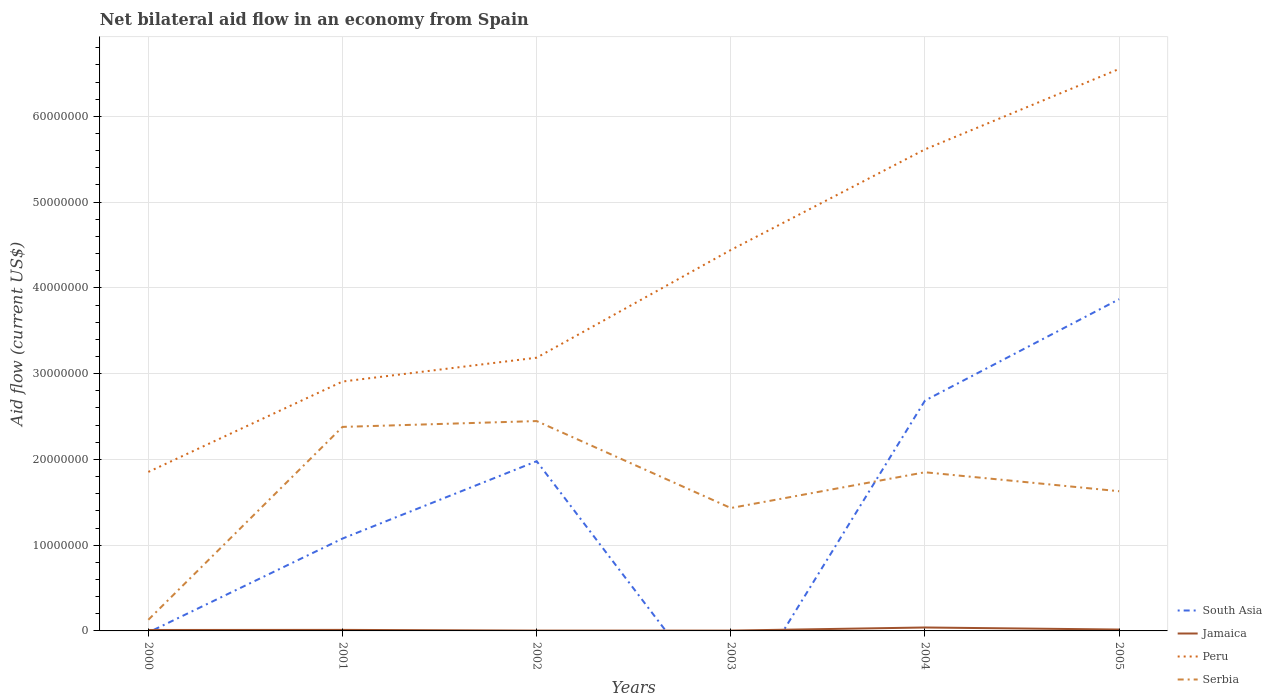Is the number of lines equal to the number of legend labels?
Offer a terse response. No. What is the total net bilateral aid flow in Peru in the graph?
Offer a very short reply. -2.71e+07. What is the difference between the highest and the second highest net bilateral aid flow in Peru?
Your answer should be compact. 4.70e+07. How many lines are there?
Offer a very short reply. 4. How many years are there in the graph?
Make the answer very short. 6. Are the values on the major ticks of Y-axis written in scientific E-notation?
Your answer should be compact. No. How many legend labels are there?
Keep it short and to the point. 4. What is the title of the graph?
Offer a terse response. Net bilateral aid flow in an economy from Spain. What is the label or title of the X-axis?
Keep it short and to the point. Years. What is the label or title of the Y-axis?
Ensure brevity in your answer.  Aid flow (current US$). What is the Aid flow (current US$) in South Asia in 2000?
Offer a terse response. 0. What is the Aid flow (current US$) of Peru in 2000?
Your answer should be very brief. 1.85e+07. What is the Aid flow (current US$) of Serbia in 2000?
Your answer should be compact. 1.30e+06. What is the Aid flow (current US$) in South Asia in 2001?
Your answer should be very brief. 1.08e+07. What is the Aid flow (current US$) of Peru in 2001?
Offer a very short reply. 2.91e+07. What is the Aid flow (current US$) in Serbia in 2001?
Your answer should be very brief. 2.38e+07. What is the Aid flow (current US$) in South Asia in 2002?
Make the answer very short. 1.98e+07. What is the Aid flow (current US$) of Jamaica in 2002?
Offer a terse response. 4.00e+04. What is the Aid flow (current US$) of Peru in 2002?
Give a very brief answer. 3.19e+07. What is the Aid flow (current US$) in Serbia in 2002?
Ensure brevity in your answer.  2.45e+07. What is the Aid flow (current US$) of South Asia in 2003?
Offer a terse response. 0. What is the Aid flow (current US$) in Peru in 2003?
Offer a very short reply. 4.44e+07. What is the Aid flow (current US$) in Serbia in 2003?
Ensure brevity in your answer.  1.43e+07. What is the Aid flow (current US$) of South Asia in 2004?
Your response must be concise. 2.69e+07. What is the Aid flow (current US$) of Jamaica in 2004?
Give a very brief answer. 4.00e+05. What is the Aid flow (current US$) in Peru in 2004?
Give a very brief answer. 5.62e+07. What is the Aid flow (current US$) in Serbia in 2004?
Your answer should be compact. 1.85e+07. What is the Aid flow (current US$) in South Asia in 2005?
Your response must be concise. 3.87e+07. What is the Aid flow (current US$) of Peru in 2005?
Ensure brevity in your answer.  6.55e+07. What is the Aid flow (current US$) in Serbia in 2005?
Your answer should be compact. 1.63e+07. Across all years, what is the maximum Aid flow (current US$) of South Asia?
Ensure brevity in your answer.  3.87e+07. Across all years, what is the maximum Aid flow (current US$) in Jamaica?
Your answer should be compact. 4.00e+05. Across all years, what is the maximum Aid flow (current US$) in Peru?
Offer a terse response. 6.55e+07. Across all years, what is the maximum Aid flow (current US$) in Serbia?
Provide a succinct answer. 2.45e+07. Across all years, what is the minimum Aid flow (current US$) in Jamaica?
Your response must be concise. 4.00e+04. Across all years, what is the minimum Aid flow (current US$) in Peru?
Provide a short and direct response. 1.85e+07. Across all years, what is the minimum Aid flow (current US$) in Serbia?
Give a very brief answer. 1.30e+06. What is the total Aid flow (current US$) of South Asia in the graph?
Ensure brevity in your answer.  9.61e+07. What is the total Aid flow (current US$) in Jamaica in the graph?
Offer a terse response. 8.70e+05. What is the total Aid flow (current US$) of Peru in the graph?
Offer a terse response. 2.46e+08. What is the total Aid flow (current US$) in Serbia in the graph?
Ensure brevity in your answer.  9.87e+07. What is the difference between the Aid flow (current US$) of Peru in 2000 and that in 2001?
Give a very brief answer. -1.05e+07. What is the difference between the Aid flow (current US$) in Serbia in 2000 and that in 2001?
Your answer should be compact. -2.25e+07. What is the difference between the Aid flow (current US$) of Jamaica in 2000 and that in 2002?
Make the answer very short. 7.00e+04. What is the difference between the Aid flow (current US$) of Peru in 2000 and that in 2002?
Ensure brevity in your answer.  -1.33e+07. What is the difference between the Aid flow (current US$) in Serbia in 2000 and that in 2002?
Provide a short and direct response. -2.32e+07. What is the difference between the Aid flow (current US$) of Jamaica in 2000 and that in 2003?
Your answer should be compact. 7.00e+04. What is the difference between the Aid flow (current US$) in Peru in 2000 and that in 2003?
Offer a terse response. -2.59e+07. What is the difference between the Aid flow (current US$) of Serbia in 2000 and that in 2003?
Provide a short and direct response. -1.30e+07. What is the difference between the Aid flow (current US$) of Jamaica in 2000 and that in 2004?
Offer a very short reply. -2.90e+05. What is the difference between the Aid flow (current US$) of Peru in 2000 and that in 2004?
Give a very brief answer. -3.76e+07. What is the difference between the Aid flow (current US$) of Serbia in 2000 and that in 2004?
Your response must be concise. -1.72e+07. What is the difference between the Aid flow (current US$) of Jamaica in 2000 and that in 2005?
Provide a short and direct response. -5.00e+04. What is the difference between the Aid flow (current US$) of Peru in 2000 and that in 2005?
Offer a terse response. -4.70e+07. What is the difference between the Aid flow (current US$) of Serbia in 2000 and that in 2005?
Give a very brief answer. -1.50e+07. What is the difference between the Aid flow (current US$) in South Asia in 2001 and that in 2002?
Offer a terse response. -9.02e+06. What is the difference between the Aid flow (current US$) in Jamaica in 2001 and that in 2002?
Offer a very short reply. 8.00e+04. What is the difference between the Aid flow (current US$) in Peru in 2001 and that in 2002?
Your answer should be compact. -2.78e+06. What is the difference between the Aid flow (current US$) of Serbia in 2001 and that in 2002?
Provide a short and direct response. -6.80e+05. What is the difference between the Aid flow (current US$) in Peru in 2001 and that in 2003?
Your answer should be compact. -1.53e+07. What is the difference between the Aid flow (current US$) of Serbia in 2001 and that in 2003?
Ensure brevity in your answer.  9.46e+06. What is the difference between the Aid flow (current US$) in South Asia in 2001 and that in 2004?
Your answer should be compact. -1.61e+07. What is the difference between the Aid flow (current US$) in Jamaica in 2001 and that in 2004?
Give a very brief answer. -2.80e+05. What is the difference between the Aid flow (current US$) in Peru in 2001 and that in 2004?
Make the answer very short. -2.71e+07. What is the difference between the Aid flow (current US$) of Serbia in 2001 and that in 2004?
Your answer should be compact. 5.29e+06. What is the difference between the Aid flow (current US$) in South Asia in 2001 and that in 2005?
Your answer should be very brief. -2.79e+07. What is the difference between the Aid flow (current US$) in Peru in 2001 and that in 2005?
Offer a very short reply. -3.64e+07. What is the difference between the Aid flow (current US$) in Serbia in 2001 and that in 2005?
Ensure brevity in your answer.  7.50e+06. What is the difference between the Aid flow (current US$) of Peru in 2002 and that in 2003?
Provide a short and direct response. -1.26e+07. What is the difference between the Aid flow (current US$) in Serbia in 2002 and that in 2003?
Provide a short and direct response. 1.01e+07. What is the difference between the Aid flow (current US$) of South Asia in 2002 and that in 2004?
Give a very brief answer. -7.07e+06. What is the difference between the Aid flow (current US$) of Jamaica in 2002 and that in 2004?
Make the answer very short. -3.60e+05. What is the difference between the Aid flow (current US$) in Peru in 2002 and that in 2004?
Give a very brief answer. -2.43e+07. What is the difference between the Aid flow (current US$) of Serbia in 2002 and that in 2004?
Offer a terse response. 5.97e+06. What is the difference between the Aid flow (current US$) of South Asia in 2002 and that in 2005?
Offer a very short reply. -1.89e+07. What is the difference between the Aid flow (current US$) in Peru in 2002 and that in 2005?
Make the answer very short. -3.37e+07. What is the difference between the Aid flow (current US$) in Serbia in 2002 and that in 2005?
Give a very brief answer. 8.18e+06. What is the difference between the Aid flow (current US$) of Jamaica in 2003 and that in 2004?
Provide a succinct answer. -3.60e+05. What is the difference between the Aid flow (current US$) in Peru in 2003 and that in 2004?
Your answer should be very brief. -1.17e+07. What is the difference between the Aid flow (current US$) of Serbia in 2003 and that in 2004?
Give a very brief answer. -4.17e+06. What is the difference between the Aid flow (current US$) of Jamaica in 2003 and that in 2005?
Your answer should be very brief. -1.20e+05. What is the difference between the Aid flow (current US$) of Peru in 2003 and that in 2005?
Your answer should be very brief. -2.11e+07. What is the difference between the Aid flow (current US$) in Serbia in 2003 and that in 2005?
Provide a succinct answer. -1.96e+06. What is the difference between the Aid flow (current US$) of South Asia in 2004 and that in 2005?
Give a very brief answer. -1.18e+07. What is the difference between the Aid flow (current US$) of Peru in 2004 and that in 2005?
Your answer should be very brief. -9.38e+06. What is the difference between the Aid flow (current US$) of Serbia in 2004 and that in 2005?
Your response must be concise. 2.21e+06. What is the difference between the Aid flow (current US$) of Jamaica in 2000 and the Aid flow (current US$) of Peru in 2001?
Your answer should be very brief. -2.90e+07. What is the difference between the Aid flow (current US$) in Jamaica in 2000 and the Aid flow (current US$) in Serbia in 2001?
Ensure brevity in your answer.  -2.37e+07. What is the difference between the Aid flow (current US$) of Peru in 2000 and the Aid flow (current US$) of Serbia in 2001?
Make the answer very short. -5.25e+06. What is the difference between the Aid flow (current US$) of Jamaica in 2000 and the Aid flow (current US$) of Peru in 2002?
Your answer should be compact. -3.18e+07. What is the difference between the Aid flow (current US$) of Jamaica in 2000 and the Aid flow (current US$) of Serbia in 2002?
Provide a succinct answer. -2.44e+07. What is the difference between the Aid flow (current US$) in Peru in 2000 and the Aid flow (current US$) in Serbia in 2002?
Your response must be concise. -5.93e+06. What is the difference between the Aid flow (current US$) in Jamaica in 2000 and the Aid flow (current US$) in Peru in 2003?
Keep it short and to the point. -4.43e+07. What is the difference between the Aid flow (current US$) in Jamaica in 2000 and the Aid flow (current US$) in Serbia in 2003?
Give a very brief answer. -1.42e+07. What is the difference between the Aid flow (current US$) of Peru in 2000 and the Aid flow (current US$) of Serbia in 2003?
Give a very brief answer. 4.21e+06. What is the difference between the Aid flow (current US$) of Jamaica in 2000 and the Aid flow (current US$) of Peru in 2004?
Ensure brevity in your answer.  -5.60e+07. What is the difference between the Aid flow (current US$) in Jamaica in 2000 and the Aid flow (current US$) in Serbia in 2004?
Make the answer very short. -1.84e+07. What is the difference between the Aid flow (current US$) of Peru in 2000 and the Aid flow (current US$) of Serbia in 2004?
Your answer should be compact. 4.00e+04. What is the difference between the Aid flow (current US$) in Jamaica in 2000 and the Aid flow (current US$) in Peru in 2005?
Ensure brevity in your answer.  -6.54e+07. What is the difference between the Aid flow (current US$) in Jamaica in 2000 and the Aid flow (current US$) in Serbia in 2005?
Your answer should be compact. -1.62e+07. What is the difference between the Aid flow (current US$) of Peru in 2000 and the Aid flow (current US$) of Serbia in 2005?
Provide a short and direct response. 2.25e+06. What is the difference between the Aid flow (current US$) of South Asia in 2001 and the Aid flow (current US$) of Jamaica in 2002?
Your response must be concise. 1.07e+07. What is the difference between the Aid flow (current US$) of South Asia in 2001 and the Aid flow (current US$) of Peru in 2002?
Ensure brevity in your answer.  -2.11e+07. What is the difference between the Aid flow (current US$) of South Asia in 2001 and the Aid flow (current US$) of Serbia in 2002?
Ensure brevity in your answer.  -1.37e+07. What is the difference between the Aid flow (current US$) of Jamaica in 2001 and the Aid flow (current US$) of Peru in 2002?
Provide a succinct answer. -3.17e+07. What is the difference between the Aid flow (current US$) of Jamaica in 2001 and the Aid flow (current US$) of Serbia in 2002?
Give a very brief answer. -2.44e+07. What is the difference between the Aid flow (current US$) of Peru in 2001 and the Aid flow (current US$) of Serbia in 2002?
Offer a very short reply. 4.61e+06. What is the difference between the Aid flow (current US$) in South Asia in 2001 and the Aid flow (current US$) in Jamaica in 2003?
Offer a very short reply. 1.07e+07. What is the difference between the Aid flow (current US$) in South Asia in 2001 and the Aid flow (current US$) in Peru in 2003?
Make the answer very short. -3.36e+07. What is the difference between the Aid flow (current US$) of South Asia in 2001 and the Aid flow (current US$) of Serbia in 2003?
Give a very brief answer. -3.56e+06. What is the difference between the Aid flow (current US$) of Jamaica in 2001 and the Aid flow (current US$) of Peru in 2003?
Offer a terse response. -4.43e+07. What is the difference between the Aid flow (current US$) in Jamaica in 2001 and the Aid flow (current US$) in Serbia in 2003?
Give a very brief answer. -1.42e+07. What is the difference between the Aid flow (current US$) in Peru in 2001 and the Aid flow (current US$) in Serbia in 2003?
Make the answer very short. 1.48e+07. What is the difference between the Aid flow (current US$) of South Asia in 2001 and the Aid flow (current US$) of Jamaica in 2004?
Ensure brevity in your answer.  1.04e+07. What is the difference between the Aid flow (current US$) of South Asia in 2001 and the Aid flow (current US$) of Peru in 2004?
Offer a very short reply. -4.54e+07. What is the difference between the Aid flow (current US$) in South Asia in 2001 and the Aid flow (current US$) in Serbia in 2004?
Offer a terse response. -7.73e+06. What is the difference between the Aid flow (current US$) of Jamaica in 2001 and the Aid flow (current US$) of Peru in 2004?
Provide a succinct answer. -5.60e+07. What is the difference between the Aid flow (current US$) in Jamaica in 2001 and the Aid flow (current US$) in Serbia in 2004?
Your answer should be very brief. -1.84e+07. What is the difference between the Aid flow (current US$) of Peru in 2001 and the Aid flow (current US$) of Serbia in 2004?
Make the answer very short. 1.06e+07. What is the difference between the Aid flow (current US$) of South Asia in 2001 and the Aid flow (current US$) of Jamaica in 2005?
Make the answer very short. 1.06e+07. What is the difference between the Aid flow (current US$) in South Asia in 2001 and the Aid flow (current US$) in Peru in 2005?
Provide a short and direct response. -5.48e+07. What is the difference between the Aid flow (current US$) of South Asia in 2001 and the Aid flow (current US$) of Serbia in 2005?
Give a very brief answer. -5.52e+06. What is the difference between the Aid flow (current US$) in Jamaica in 2001 and the Aid flow (current US$) in Peru in 2005?
Provide a succinct answer. -6.54e+07. What is the difference between the Aid flow (current US$) in Jamaica in 2001 and the Aid flow (current US$) in Serbia in 2005?
Keep it short and to the point. -1.62e+07. What is the difference between the Aid flow (current US$) of Peru in 2001 and the Aid flow (current US$) of Serbia in 2005?
Provide a succinct answer. 1.28e+07. What is the difference between the Aid flow (current US$) in South Asia in 2002 and the Aid flow (current US$) in Jamaica in 2003?
Your answer should be compact. 1.98e+07. What is the difference between the Aid flow (current US$) of South Asia in 2002 and the Aid flow (current US$) of Peru in 2003?
Your response must be concise. -2.46e+07. What is the difference between the Aid flow (current US$) of South Asia in 2002 and the Aid flow (current US$) of Serbia in 2003?
Offer a terse response. 5.46e+06. What is the difference between the Aid flow (current US$) of Jamaica in 2002 and the Aid flow (current US$) of Peru in 2003?
Your response must be concise. -4.44e+07. What is the difference between the Aid flow (current US$) in Jamaica in 2002 and the Aid flow (current US$) in Serbia in 2003?
Offer a very short reply. -1.43e+07. What is the difference between the Aid flow (current US$) of Peru in 2002 and the Aid flow (current US$) of Serbia in 2003?
Offer a very short reply. 1.75e+07. What is the difference between the Aid flow (current US$) of South Asia in 2002 and the Aid flow (current US$) of Jamaica in 2004?
Provide a short and direct response. 1.94e+07. What is the difference between the Aid flow (current US$) in South Asia in 2002 and the Aid flow (current US$) in Peru in 2004?
Provide a succinct answer. -3.64e+07. What is the difference between the Aid flow (current US$) of South Asia in 2002 and the Aid flow (current US$) of Serbia in 2004?
Give a very brief answer. 1.29e+06. What is the difference between the Aid flow (current US$) in Jamaica in 2002 and the Aid flow (current US$) in Peru in 2004?
Provide a short and direct response. -5.61e+07. What is the difference between the Aid flow (current US$) in Jamaica in 2002 and the Aid flow (current US$) in Serbia in 2004?
Offer a very short reply. -1.85e+07. What is the difference between the Aid flow (current US$) in Peru in 2002 and the Aid flow (current US$) in Serbia in 2004?
Your response must be concise. 1.34e+07. What is the difference between the Aid flow (current US$) in South Asia in 2002 and the Aid flow (current US$) in Jamaica in 2005?
Give a very brief answer. 1.96e+07. What is the difference between the Aid flow (current US$) in South Asia in 2002 and the Aid flow (current US$) in Peru in 2005?
Your answer should be very brief. -4.57e+07. What is the difference between the Aid flow (current US$) of South Asia in 2002 and the Aid flow (current US$) of Serbia in 2005?
Your answer should be compact. 3.50e+06. What is the difference between the Aid flow (current US$) in Jamaica in 2002 and the Aid flow (current US$) in Peru in 2005?
Provide a succinct answer. -6.55e+07. What is the difference between the Aid flow (current US$) in Jamaica in 2002 and the Aid flow (current US$) in Serbia in 2005?
Keep it short and to the point. -1.62e+07. What is the difference between the Aid flow (current US$) in Peru in 2002 and the Aid flow (current US$) in Serbia in 2005?
Provide a short and direct response. 1.56e+07. What is the difference between the Aid flow (current US$) in Jamaica in 2003 and the Aid flow (current US$) in Peru in 2004?
Your answer should be very brief. -5.61e+07. What is the difference between the Aid flow (current US$) in Jamaica in 2003 and the Aid flow (current US$) in Serbia in 2004?
Give a very brief answer. -1.85e+07. What is the difference between the Aid flow (current US$) of Peru in 2003 and the Aid flow (current US$) of Serbia in 2004?
Provide a succinct answer. 2.59e+07. What is the difference between the Aid flow (current US$) in Jamaica in 2003 and the Aid flow (current US$) in Peru in 2005?
Provide a short and direct response. -6.55e+07. What is the difference between the Aid flow (current US$) in Jamaica in 2003 and the Aid flow (current US$) in Serbia in 2005?
Offer a terse response. -1.62e+07. What is the difference between the Aid flow (current US$) of Peru in 2003 and the Aid flow (current US$) of Serbia in 2005?
Keep it short and to the point. 2.81e+07. What is the difference between the Aid flow (current US$) of South Asia in 2004 and the Aid flow (current US$) of Jamaica in 2005?
Your answer should be compact. 2.67e+07. What is the difference between the Aid flow (current US$) of South Asia in 2004 and the Aid flow (current US$) of Peru in 2005?
Ensure brevity in your answer.  -3.87e+07. What is the difference between the Aid flow (current US$) of South Asia in 2004 and the Aid flow (current US$) of Serbia in 2005?
Provide a short and direct response. 1.06e+07. What is the difference between the Aid flow (current US$) of Jamaica in 2004 and the Aid flow (current US$) of Peru in 2005?
Give a very brief answer. -6.51e+07. What is the difference between the Aid flow (current US$) in Jamaica in 2004 and the Aid flow (current US$) in Serbia in 2005?
Keep it short and to the point. -1.59e+07. What is the difference between the Aid flow (current US$) in Peru in 2004 and the Aid flow (current US$) in Serbia in 2005?
Provide a succinct answer. 3.99e+07. What is the average Aid flow (current US$) of South Asia per year?
Offer a very short reply. 1.60e+07. What is the average Aid flow (current US$) of Jamaica per year?
Your answer should be very brief. 1.45e+05. What is the average Aid flow (current US$) in Peru per year?
Your answer should be very brief. 4.09e+07. What is the average Aid flow (current US$) of Serbia per year?
Provide a short and direct response. 1.64e+07. In the year 2000, what is the difference between the Aid flow (current US$) of Jamaica and Aid flow (current US$) of Peru?
Give a very brief answer. -1.84e+07. In the year 2000, what is the difference between the Aid flow (current US$) in Jamaica and Aid flow (current US$) in Serbia?
Give a very brief answer. -1.19e+06. In the year 2000, what is the difference between the Aid flow (current US$) in Peru and Aid flow (current US$) in Serbia?
Offer a very short reply. 1.72e+07. In the year 2001, what is the difference between the Aid flow (current US$) of South Asia and Aid flow (current US$) of Jamaica?
Your response must be concise. 1.06e+07. In the year 2001, what is the difference between the Aid flow (current US$) of South Asia and Aid flow (current US$) of Peru?
Your answer should be compact. -1.83e+07. In the year 2001, what is the difference between the Aid flow (current US$) of South Asia and Aid flow (current US$) of Serbia?
Make the answer very short. -1.30e+07. In the year 2001, what is the difference between the Aid flow (current US$) in Jamaica and Aid flow (current US$) in Peru?
Ensure brevity in your answer.  -2.90e+07. In the year 2001, what is the difference between the Aid flow (current US$) in Jamaica and Aid flow (current US$) in Serbia?
Keep it short and to the point. -2.37e+07. In the year 2001, what is the difference between the Aid flow (current US$) in Peru and Aid flow (current US$) in Serbia?
Offer a very short reply. 5.29e+06. In the year 2002, what is the difference between the Aid flow (current US$) of South Asia and Aid flow (current US$) of Jamaica?
Your response must be concise. 1.98e+07. In the year 2002, what is the difference between the Aid flow (current US$) of South Asia and Aid flow (current US$) of Peru?
Provide a succinct answer. -1.21e+07. In the year 2002, what is the difference between the Aid flow (current US$) of South Asia and Aid flow (current US$) of Serbia?
Keep it short and to the point. -4.68e+06. In the year 2002, what is the difference between the Aid flow (current US$) in Jamaica and Aid flow (current US$) in Peru?
Your answer should be very brief. -3.18e+07. In the year 2002, what is the difference between the Aid flow (current US$) in Jamaica and Aid flow (current US$) in Serbia?
Ensure brevity in your answer.  -2.44e+07. In the year 2002, what is the difference between the Aid flow (current US$) of Peru and Aid flow (current US$) of Serbia?
Your answer should be very brief. 7.39e+06. In the year 2003, what is the difference between the Aid flow (current US$) of Jamaica and Aid flow (current US$) of Peru?
Make the answer very short. -4.44e+07. In the year 2003, what is the difference between the Aid flow (current US$) in Jamaica and Aid flow (current US$) in Serbia?
Give a very brief answer. -1.43e+07. In the year 2003, what is the difference between the Aid flow (current US$) of Peru and Aid flow (current US$) of Serbia?
Your answer should be compact. 3.01e+07. In the year 2004, what is the difference between the Aid flow (current US$) of South Asia and Aid flow (current US$) of Jamaica?
Your answer should be compact. 2.65e+07. In the year 2004, what is the difference between the Aid flow (current US$) in South Asia and Aid flow (current US$) in Peru?
Make the answer very short. -2.93e+07. In the year 2004, what is the difference between the Aid flow (current US$) of South Asia and Aid flow (current US$) of Serbia?
Provide a succinct answer. 8.36e+06. In the year 2004, what is the difference between the Aid flow (current US$) in Jamaica and Aid flow (current US$) in Peru?
Offer a very short reply. -5.58e+07. In the year 2004, what is the difference between the Aid flow (current US$) of Jamaica and Aid flow (current US$) of Serbia?
Make the answer very short. -1.81e+07. In the year 2004, what is the difference between the Aid flow (current US$) in Peru and Aid flow (current US$) in Serbia?
Your answer should be compact. 3.76e+07. In the year 2005, what is the difference between the Aid flow (current US$) of South Asia and Aid flow (current US$) of Jamaica?
Ensure brevity in your answer.  3.85e+07. In the year 2005, what is the difference between the Aid flow (current US$) of South Asia and Aid flow (current US$) of Peru?
Provide a short and direct response. -2.68e+07. In the year 2005, what is the difference between the Aid flow (current US$) in South Asia and Aid flow (current US$) in Serbia?
Provide a succinct answer. 2.24e+07. In the year 2005, what is the difference between the Aid flow (current US$) of Jamaica and Aid flow (current US$) of Peru?
Make the answer very short. -6.54e+07. In the year 2005, what is the difference between the Aid flow (current US$) of Jamaica and Aid flow (current US$) of Serbia?
Provide a succinct answer. -1.61e+07. In the year 2005, what is the difference between the Aid flow (current US$) in Peru and Aid flow (current US$) in Serbia?
Give a very brief answer. 4.92e+07. What is the ratio of the Aid flow (current US$) of Peru in 2000 to that in 2001?
Your answer should be very brief. 0.64. What is the ratio of the Aid flow (current US$) in Serbia in 2000 to that in 2001?
Offer a terse response. 0.05. What is the ratio of the Aid flow (current US$) in Jamaica in 2000 to that in 2002?
Provide a short and direct response. 2.75. What is the ratio of the Aid flow (current US$) of Peru in 2000 to that in 2002?
Your answer should be compact. 0.58. What is the ratio of the Aid flow (current US$) of Serbia in 2000 to that in 2002?
Keep it short and to the point. 0.05. What is the ratio of the Aid flow (current US$) in Jamaica in 2000 to that in 2003?
Provide a succinct answer. 2.75. What is the ratio of the Aid flow (current US$) of Peru in 2000 to that in 2003?
Ensure brevity in your answer.  0.42. What is the ratio of the Aid flow (current US$) in Serbia in 2000 to that in 2003?
Make the answer very short. 0.09. What is the ratio of the Aid flow (current US$) in Jamaica in 2000 to that in 2004?
Ensure brevity in your answer.  0.28. What is the ratio of the Aid flow (current US$) in Peru in 2000 to that in 2004?
Provide a short and direct response. 0.33. What is the ratio of the Aid flow (current US$) in Serbia in 2000 to that in 2004?
Your answer should be compact. 0.07. What is the ratio of the Aid flow (current US$) in Jamaica in 2000 to that in 2005?
Give a very brief answer. 0.69. What is the ratio of the Aid flow (current US$) of Peru in 2000 to that in 2005?
Your response must be concise. 0.28. What is the ratio of the Aid flow (current US$) of Serbia in 2000 to that in 2005?
Give a very brief answer. 0.08. What is the ratio of the Aid flow (current US$) in South Asia in 2001 to that in 2002?
Provide a succinct answer. 0.54. What is the ratio of the Aid flow (current US$) in Jamaica in 2001 to that in 2002?
Ensure brevity in your answer.  3. What is the ratio of the Aid flow (current US$) in Peru in 2001 to that in 2002?
Provide a succinct answer. 0.91. What is the ratio of the Aid flow (current US$) of Serbia in 2001 to that in 2002?
Keep it short and to the point. 0.97. What is the ratio of the Aid flow (current US$) of Peru in 2001 to that in 2003?
Make the answer very short. 0.65. What is the ratio of the Aid flow (current US$) in Serbia in 2001 to that in 2003?
Offer a terse response. 1.66. What is the ratio of the Aid flow (current US$) of South Asia in 2001 to that in 2004?
Offer a very short reply. 0.4. What is the ratio of the Aid flow (current US$) of Peru in 2001 to that in 2004?
Offer a very short reply. 0.52. What is the ratio of the Aid flow (current US$) in Serbia in 2001 to that in 2004?
Provide a short and direct response. 1.29. What is the ratio of the Aid flow (current US$) of South Asia in 2001 to that in 2005?
Give a very brief answer. 0.28. What is the ratio of the Aid flow (current US$) of Peru in 2001 to that in 2005?
Give a very brief answer. 0.44. What is the ratio of the Aid flow (current US$) in Serbia in 2001 to that in 2005?
Provide a short and direct response. 1.46. What is the ratio of the Aid flow (current US$) of Peru in 2002 to that in 2003?
Your answer should be very brief. 0.72. What is the ratio of the Aid flow (current US$) in Serbia in 2002 to that in 2003?
Give a very brief answer. 1.71. What is the ratio of the Aid flow (current US$) of South Asia in 2002 to that in 2004?
Your response must be concise. 0.74. What is the ratio of the Aid flow (current US$) in Jamaica in 2002 to that in 2004?
Ensure brevity in your answer.  0.1. What is the ratio of the Aid flow (current US$) of Peru in 2002 to that in 2004?
Make the answer very short. 0.57. What is the ratio of the Aid flow (current US$) of Serbia in 2002 to that in 2004?
Your answer should be compact. 1.32. What is the ratio of the Aid flow (current US$) of South Asia in 2002 to that in 2005?
Offer a very short reply. 0.51. What is the ratio of the Aid flow (current US$) of Peru in 2002 to that in 2005?
Your answer should be compact. 0.49. What is the ratio of the Aid flow (current US$) in Serbia in 2002 to that in 2005?
Your answer should be very brief. 1.5. What is the ratio of the Aid flow (current US$) in Jamaica in 2003 to that in 2004?
Provide a short and direct response. 0.1. What is the ratio of the Aid flow (current US$) in Peru in 2003 to that in 2004?
Give a very brief answer. 0.79. What is the ratio of the Aid flow (current US$) of Serbia in 2003 to that in 2004?
Ensure brevity in your answer.  0.77. What is the ratio of the Aid flow (current US$) of Peru in 2003 to that in 2005?
Offer a terse response. 0.68. What is the ratio of the Aid flow (current US$) in Serbia in 2003 to that in 2005?
Offer a very short reply. 0.88. What is the ratio of the Aid flow (current US$) of South Asia in 2004 to that in 2005?
Keep it short and to the point. 0.69. What is the ratio of the Aid flow (current US$) in Peru in 2004 to that in 2005?
Your answer should be very brief. 0.86. What is the ratio of the Aid flow (current US$) of Serbia in 2004 to that in 2005?
Your response must be concise. 1.14. What is the difference between the highest and the second highest Aid flow (current US$) of South Asia?
Provide a short and direct response. 1.18e+07. What is the difference between the highest and the second highest Aid flow (current US$) in Jamaica?
Give a very brief answer. 2.40e+05. What is the difference between the highest and the second highest Aid flow (current US$) of Peru?
Your answer should be very brief. 9.38e+06. What is the difference between the highest and the second highest Aid flow (current US$) of Serbia?
Offer a very short reply. 6.80e+05. What is the difference between the highest and the lowest Aid flow (current US$) of South Asia?
Give a very brief answer. 3.87e+07. What is the difference between the highest and the lowest Aid flow (current US$) in Peru?
Offer a terse response. 4.70e+07. What is the difference between the highest and the lowest Aid flow (current US$) in Serbia?
Offer a very short reply. 2.32e+07. 